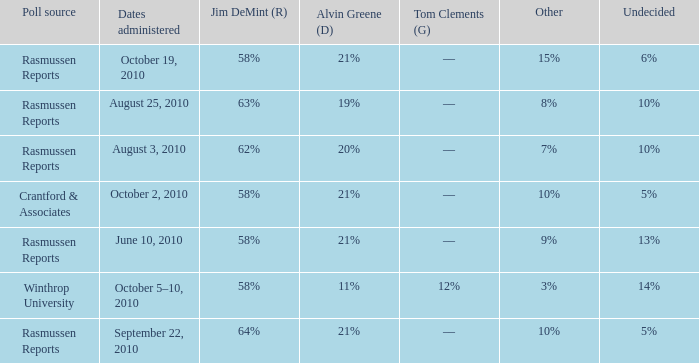Which poll source determined undecided of 5% and Jim DeMint (R) of 58%? Crantford & Associates. 